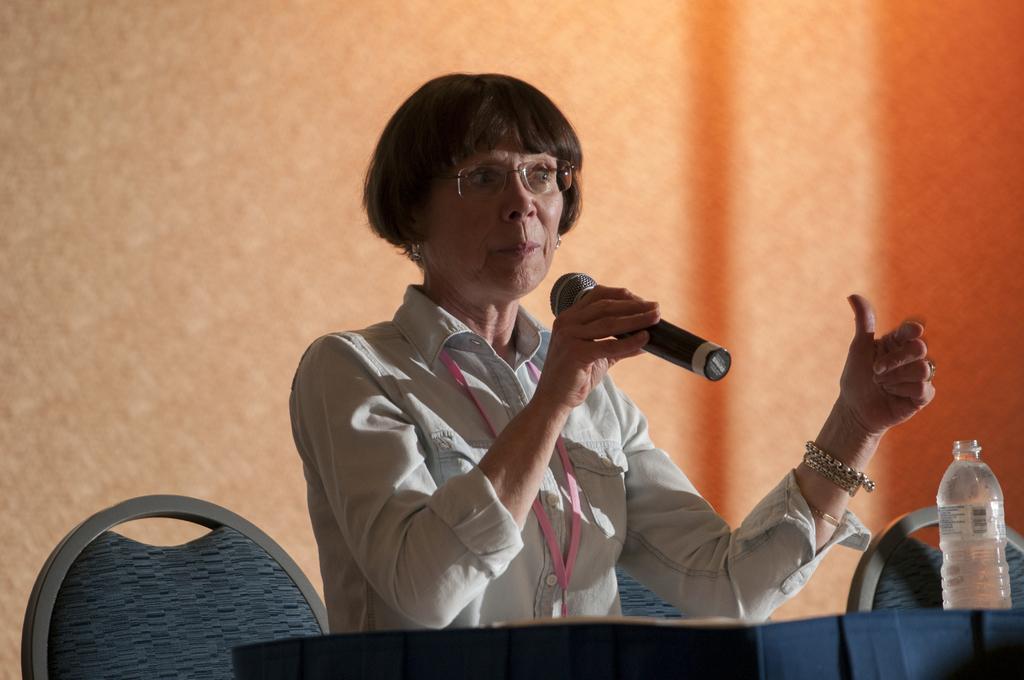Could you give a brief overview of what you see in this image? A woman is talking on mic by sitting on the chair at the table. On the right there is a bottle. 